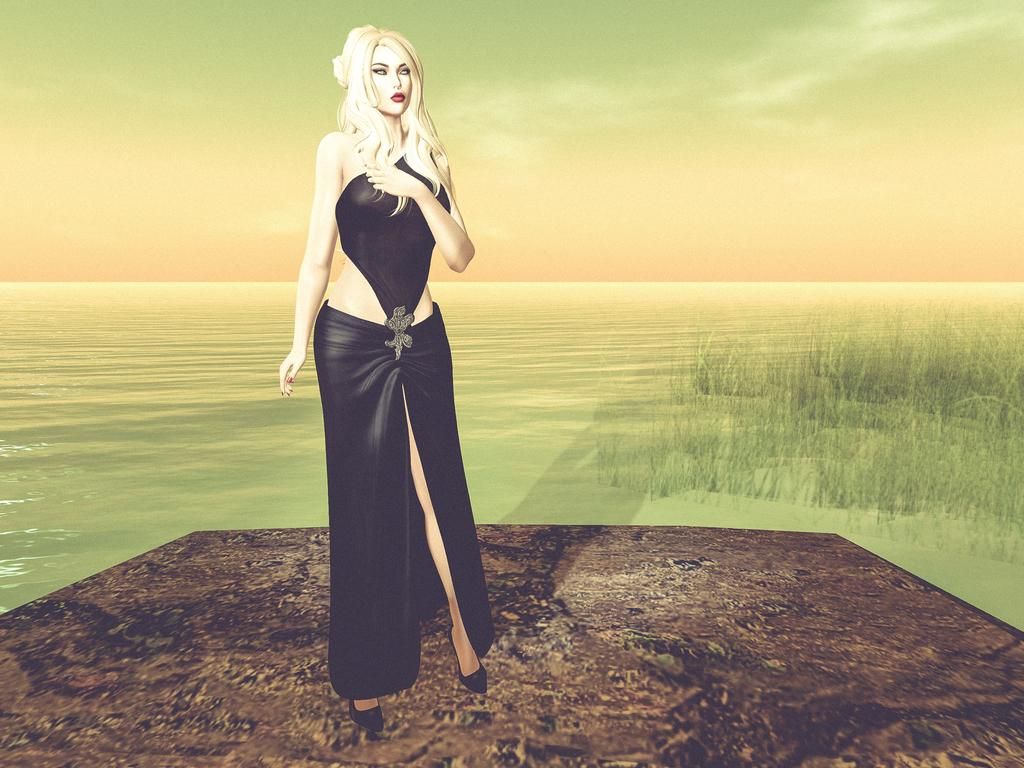What type of artwork is depicted in the image? The image is a painting. Who is featured in the painting? There is a woman in the painting. What is the woman wearing? The woman is wearing a black dress. What is the woman doing in the painting? The woman is standing in the painting. What natural element can be seen in the painting? There is a river in the painting. What part of the environment is visible in the painting? The sky is visible in the painting. What type of rice is being cooked by the woman in the painting? There is no rice present in the painting; the woman is wearing a black dress and standing near a river. 